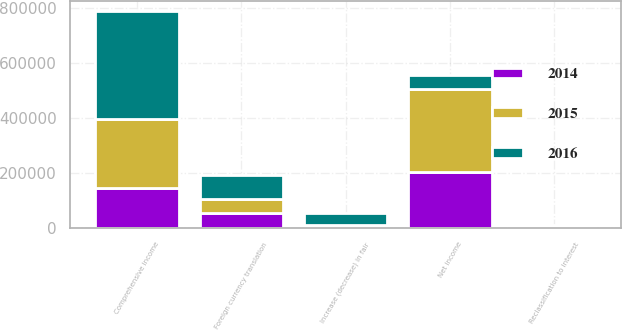Convert chart. <chart><loc_0><loc_0><loc_500><loc_500><stacked_bar_chart><ecel><fcel>Net income<fcel>Foreign currency translation<fcel>Increase (decrease) in fair<fcel>Reclassification to interest<fcel>Comprehensive income<nl><fcel>2016<fcel>52059<fcel>86621<fcel>41998<fcel>4968<fcel>392197<nl><fcel>2015<fcel>300226<fcel>51745<fcel>3407<fcel>2621<fcel>247695<nl><fcel>2014<fcel>203415<fcel>52373<fcel>7936<fcel>3419<fcel>146525<nl></chart> 